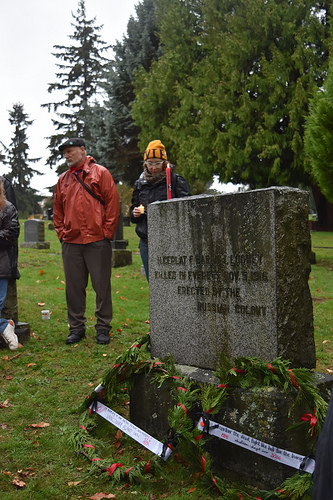<image>
Is there a man above the land? No. The man is not positioned above the land. The vertical arrangement shows a different relationship. 